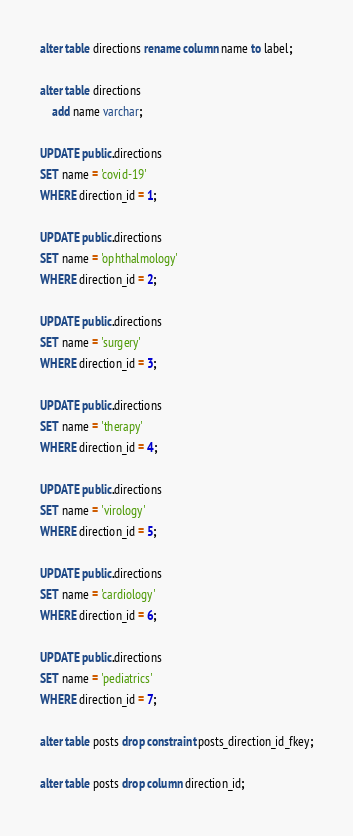Convert code to text. <code><loc_0><loc_0><loc_500><loc_500><_SQL_>alter table directions rename column name to label;

alter table directions
    add name varchar;

UPDATE public.directions
SET name = 'covid-19'
WHERE direction_id = 1;

UPDATE public.directions
SET name = 'ophthalmology'
WHERE direction_id = 2;

UPDATE public.directions
SET name = 'surgery'
WHERE direction_id = 3;

UPDATE public.directions
SET name = 'therapy'
WHERE direction_id = 4;

UPDATE public.directions
SET name = 'virology'
WHERE direction_id = 5;

UPDATE public.directions
SET name = 'cardiology'
WHERE direction_id = 6;

UPDATE public.directions
SET name = 'pediatrics'
WHERE direction_id = 7;

alter table posts drop constraint posts_direction_id_fkey;

alter table posts drop column direction_id;</code> 